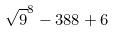Convert formula to latex. <formula><loc_0><loc_0><loc_500><loc_500>\sqrt { 9 } ^ { 8 } - 3 8 8 + 6</formula> 